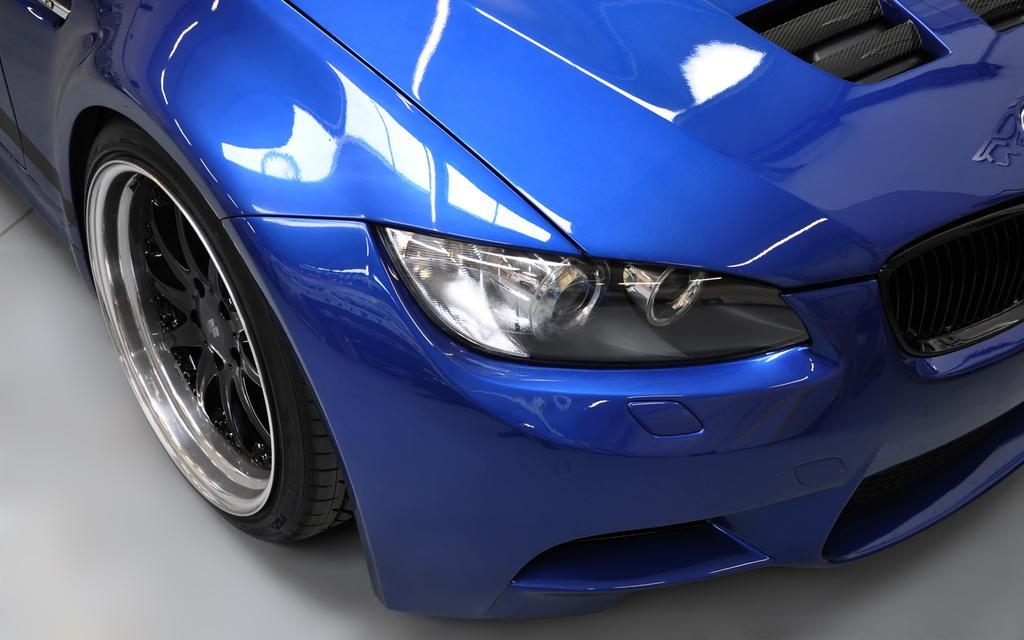Can you describe this image briefly? In this image in front there is a blue car on the floor. 